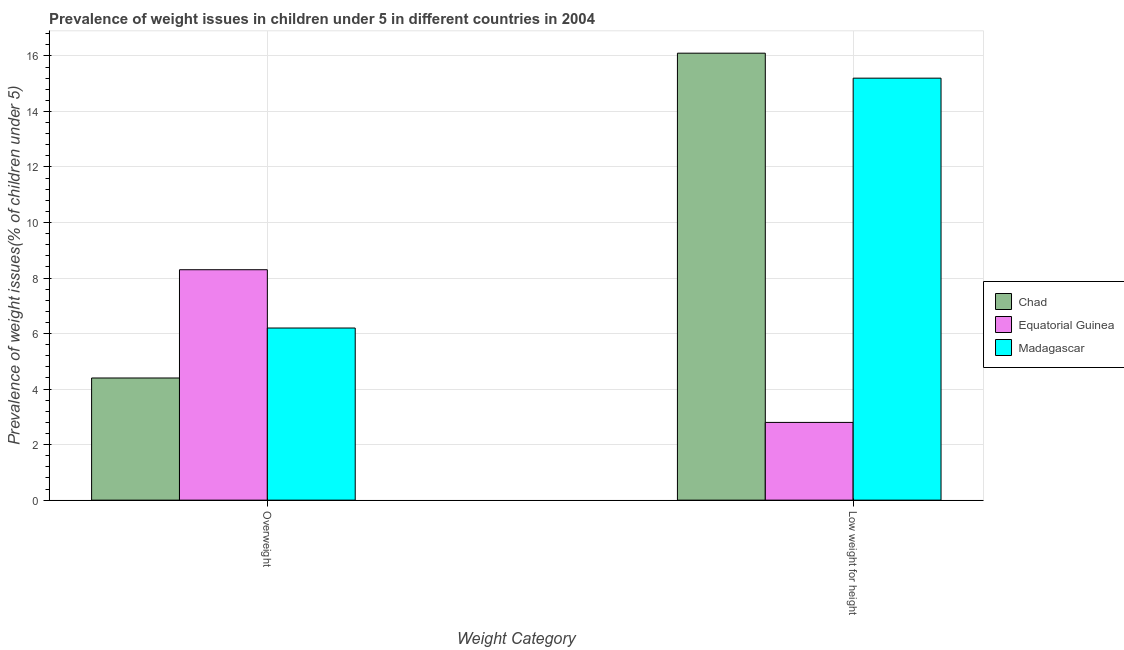How many different coloured bars are there?
Offer a terse response. 3. How many groups of bars are there?
Offer a very short reply. 2. Are the number of bars on each tick of the X-axis equal?
Your answer should be very brief. Yes. How many bars are there on the 2nd tick from the left?
Your answer should be compact. 3. How many bars are there on the 2nd tick from the right?
Provide a succinct answer. 3. What is the label of the 2nd group of bars from the left?
Keep it short and to the point. Low weight for height. What is the percentage of overweight children in Madagascar?
Keep it short and to the point. 6.2. Across all countries, what is the maximum percentage of underweight children?
Your answer should be very brief. 16.1. Across all countries, what is the minimum percentage of overweight children?
Ensure brevity in your answer.  4.4. In which country was the percentage of underweight children maximum?
Your answer should be compact. Chad. In which country was the percentage of overweight children minimum?
Provide a succinct answer. Chad. What is the total percentage of underweight children in the graph?
Offer a terse response. 34.1. What is the difference between the percentage of overweight children in Equatorial Guinea and that in Chad?
Keep it short and to the point. 3.9. What is the difference between the percentage of overweight children in Madagascar and the percentage of underweight children in Chad?
Your answer should be compact. -9.9. What is the average percentage of overweight children per country?
Give a very brief answer. 6.3. What is the difference between the percentage of overweight children and percentage of underweight children in Chad?
Ensure brevity in your answer.  -11.7. In how many countries, is the percentage of overweight children greater than 4.4 %?
Your answer should be compact. 3. What is the ratio of the percentage of overweight children in Chad to that in Equatorial Guinea?
Offer a terse response. 0.53. Is the percentage of underweight children in Madagascar less than that in Chad?
Keep it short and to the point. Yes. What does the 2nd bar from the left in Low weight for height represents?
Your response must be concise. Equatorial Guinea. What does the 1st bar from the right in Overweight represents?
Ensure brevity in your answer.  Madagascar. How many countries are there in the graph?
Your answer should be very brief. 3. Does the graph contain grids?
Offer a very short reply. Yes. Where does the legend appear in the graph?
Provide a short and direct response. Center right. What is the title of the graph?
Offer a terse response. Prevalence of weight issues in children under 5 in different countries in 2004. What is the label or title of the X-axis?
Your response must be concise. Weight Category. What is the label or title of the Y-axis?
Provide a short and direct response. Prevalence of weight issues(% of children under 5). What is the Prevalence of weight issues(% of children under 5) of Chad in Overweight?
Your response must be concise. 4.4. What is the Prevalence of weight issues(% of children under 5) in Equatorial Guinea in Overweight?
Keep it short and to the point. 8.3. What is the Prevalence of weight issues(% of children under 5) in Madagascar in Overweight?
Your answer should be very brief. 6.2. What is the Prevalence of weight issues(% of children under 5) of Chad in Low weight for height?
Your answer should be compact. 16.1. What is the Prevalence of weight issues(% of children under 5) of Equatorial Guinea in Low weight for height?
Provide a short and direct response. 2.8. What is the Prevalence of weight issues(% of children under 5) in Madagascar in Low weight for height?
Your answer should be very brief. 15.2. Across all Weight Category, what is the maximum Prevalence of weight issues(% of children under 5) of Chad?
Your answer should be very brief. 16.1. Across all Weight Category, what is the maximum Prevalence of weight issues(% of children under 5) in Equatorial Guinea?
Provide a succinct answer. 8.3. Across all Weight Category, what is the maximum Prevalence of weight issues(% of children under 5) of Madagascar?
Keep it short and to the point. 15.2. Across all Weight Category, what is the minimum Prevalence of weight issues(% of children under 5) in Chad?
Keep it short and to the point. 4.4. Across all Weight Category, what is the minimum Prevalence of weight issues(% of children under 5) of Equatorial Guinea?
Offer a very short reply. 2.8. Across all Weight Category, what is the minimum Prevalence of weight issues(% of children under 5) of Madagascar?
Your answer should be compact. 6.2. What is the total Prevalence of weight issues(% of children under 5) of Chad in the graph?
Provide a short and direct response. 20.5. What is the total Prevalence of weight issues(% of children under 5) of Madagascar in the graph?
Keep it short and to the point. 21.4. What is the difference between the Prevalence of weight issues(% of children under 5) of Chad in Overweight and that in Low weight for height?
Your answer should be very brief. -11.7. What is the difference between the Prevalence of weight issues(% of children under 5) of Madagascar in Overweight and that in Low weight for height?
Keep it short and to the point. -9. What is the average Prevalence of weight issues(% of children under 5) in Chad per Weight Category?
Ensure brevity in your answer.  10.25. What is the average Prevalence of weight issues(% of children under 5) in Equatorial Guinea per Weight Category?
Your answer should be very brief. 5.55. What is the average Prevalence of weight issues(% of children under 5) in Madagascar per Weight Category?
Make the answer very short. 10.7. What is the difference between the Prevalence of weight issues(% of children under 5) in Chad and Prevalence of weight issues(% of children under 5) in Equatorial Guinea in Overweight?
Provide a succinct answer. -3.9. What is the difference between the Prevalence of weight issues(% of children under 5) of Equatorial Guinea and Prevalence of weight issues(% of children under 5) of Madagascar in Overweight?
Make the answer very short. 2.1. What is the difference between the Prevalence of weight issues(% of children under 5) in Chad and Prevalence of weight issues(% of children under 5) in Madagascar in Low weight for height?
Your answer should be very brief. 0.9. What is the difference between the Prevalence of weight issues(% of children under 5) of Equatorial Guinea and Prevalence of weight issues(% of children under 5) of Madagascar in Low weight for height?
Make the answer very short. -12.4. What is the ratio of the Prevalence of weight issues(% of children under 5) in Chad in Overweight to that in Low weight for height?
Your response must be concise. 0.27. What is the ratio of the Prevalence of weight issues(% of children under 5) of Equatorial Guinea in Overweight to that in Low weight for height?
Keep it short and to the point. 2.96. What is the ratio of the Prevalence of weight issues(% of children under 5) in Madagascar in Overweight to that in Low weight for height?
Offer a very short reply. 0.41. What is the difference between the highest and the second highest Prevalence of weight issues(% of children under 5) of Chad?
Keep it short and to the point. 11.7. What is the difference between the highest and the second highest Prevalence of weight issues(% of children under 5) in Equatorial Guinea?
Your answer should be very brief. 5.5. What is the difference between the highest and the lowest Prevalence of weight issues(% of children under 5) of Madagascar?
Make the answer very short. 9. 